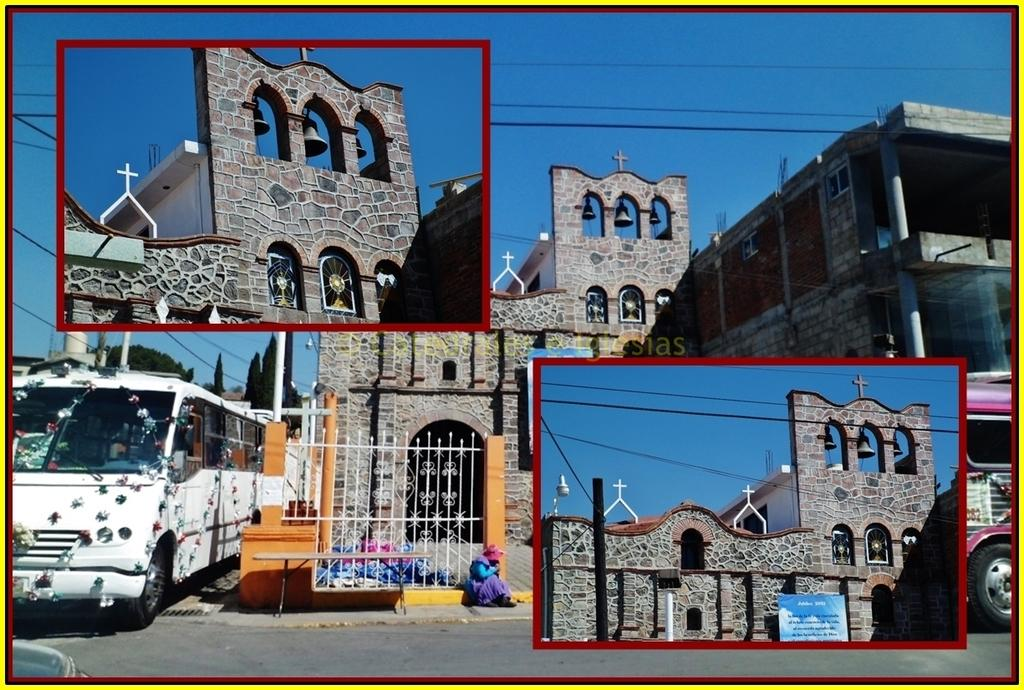How many photos can be seen in the image? There are two photos in the image. What else is visible besides the photos? There is a building and vehicles present in the image. What is the color of the sky in the image? The sky is blue in the image. What type of oatmeal is being served in the yard in the image? There is no yard or oatmeal present in the image. 